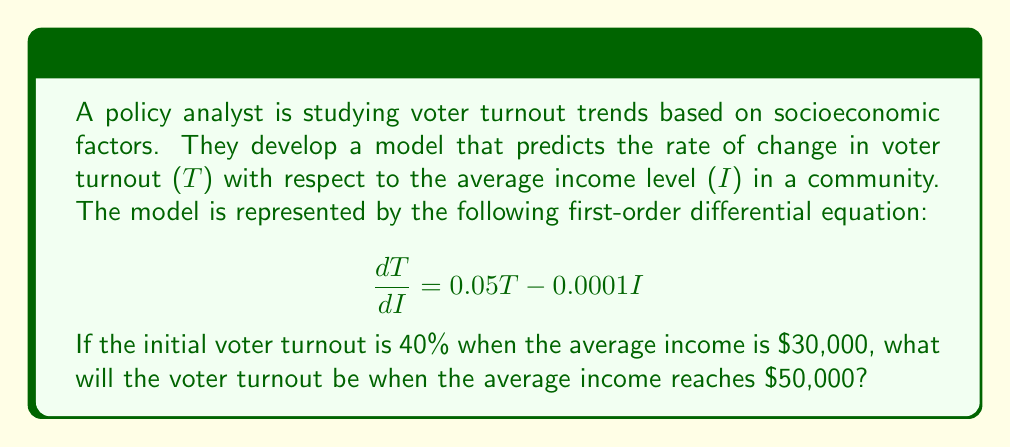Solve this math problem. To solve this problem, we need to use the method for solving first-order linear differential equations. The general form of such equations is:

$$\frac{dy}{dx} + P(x)y = Q(x)$$

In our case:
y = T (voter turnout)
x = I (average income)
P(I) = -0.05
Q(I) = -0.0001I

Step 1: Find the integrating factor
The integrating factor is given by $e^{\int P(x)dx}$
$$\mu(I) = e^{\int -0.05 dI} = e^{-0.05I}$$

Step 2: Multiply both sides of the original equation by the integrating factor
$$(e^{-0.05I})\frac{dT}{dI} + (e^{-0.05I})(0.05T) = (e^{-0.05I})(-0.0001I)$$

This can be rewritten as:
$$\frac{d}{dI}(e^{-0.05I}T) = -0.0001Ie^{-0.05I}$$

Step 3: Integrate both sides
$$\int \frac{d}{dI}(e^{-0.05I}T) dI = \int -0.0001Ie^{-0.05I} dI$$

$$e^{-0.05I}T = \int -0.0001Ie^{-0.05I} dI$$

To solve the integral on the right side, we use integration by parts:
$$\int -0.0001Ie^{-0.05I} dI = -0.0001 \left(-\frac{1}{0.05}Ie^{-0.05I} - \frac{1}{0.05^2}e^{-0.05I}\right) + C$$

$$= 0.002Ie^{-0.05I} + 0.04e^{-0.05I} + C$$

Step 4: Solve for T
$$T = 0.002I + 0.04 + Ce^{0.05I}$$

Step 5: Use the initial condition to find C
When I = 30,000 and T = 0.4 (40%)
$$0.4 = 0.002(30,000) + 0.04 + Ce^{0.05(30,000)}$$
$$C = (0.4 - 60 - 0.04)e^{-1500} \approx 1.0087 \times 10^{-650}$$

Step 6: Write the final solution
$$T = 0.002I + 0.04 + (1.0087 \times 10^{-650})e^{0.05I}$$

Step 7: Calculate T when I = 50,000
$$T = 0.002(50,000) + 0.04 + (1.0087 \times 10^{-650})e^{0.05(50,000)}$$
$$T = 100 + 0.04 + (1.0087 \times 10^{-650})(5.184705528587072 \times 10^{1082})$$
$$T \approx 100.04$$
Answer: The voter turnout will be approximately 100.04% when the average income reaches $50,000. However, since voter turnout cannot exceed 100%, we would interpret this result as predicting a voter turnout very close to 100% under these conditions. 